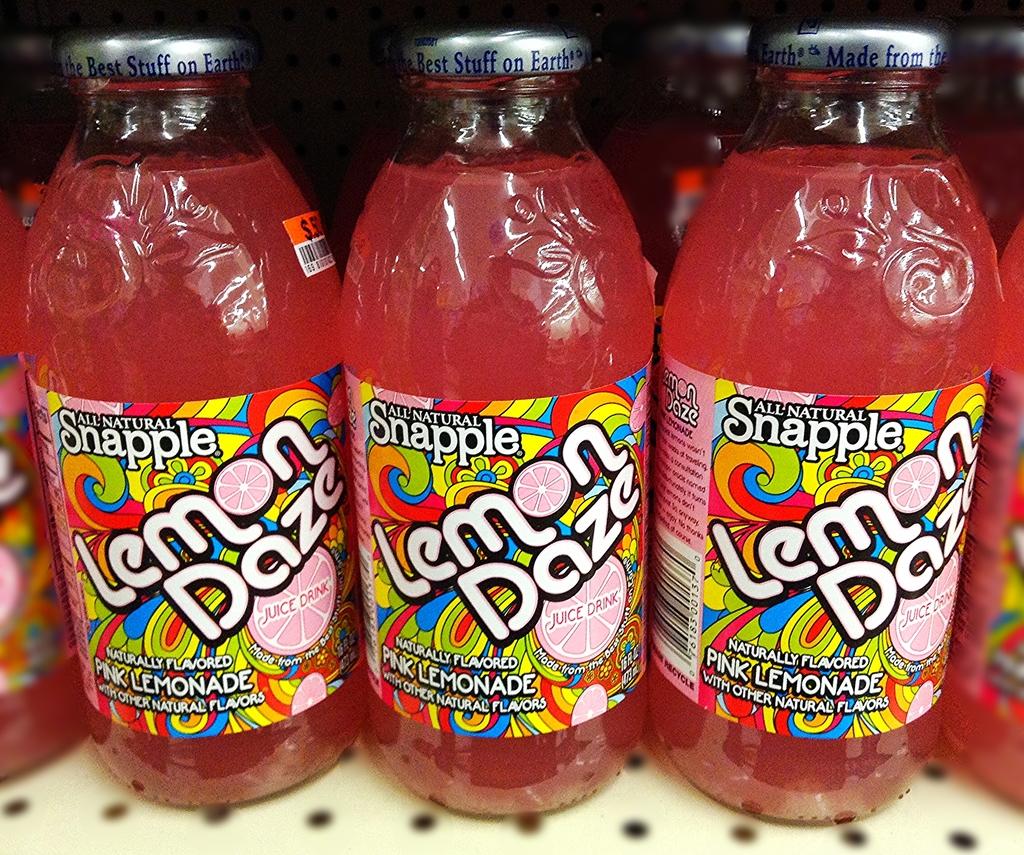The snaple drink flavor is lemon daze?
Your answer should be compact. Yes. 